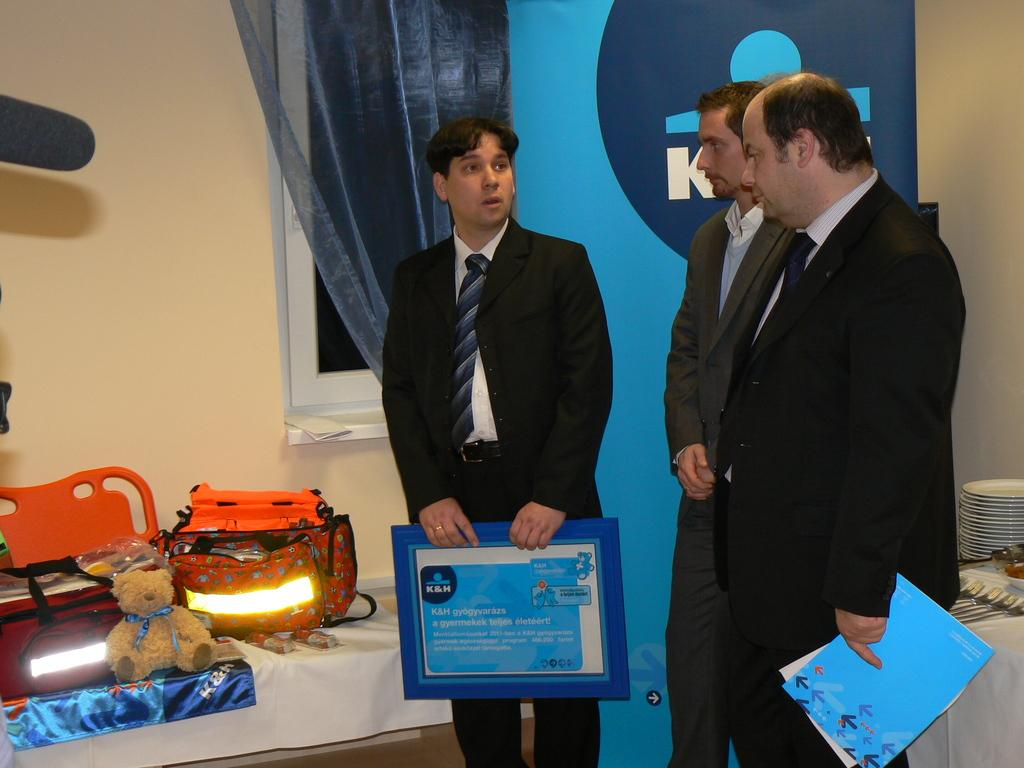What is the man in the image wearing? The man is wearing a black coat and black trousers. What accessory is the man wearing in the image? The man is wearing a tie. What is the man holding in the image? The man is holding a blue file in his hands. What can be seen on the left side of the image? There are lights and a teddy bear on the left side of the image. What is the name of the man's owner in the image? There is no indication in the image that the man has an owner, as he appears to be an adult. 